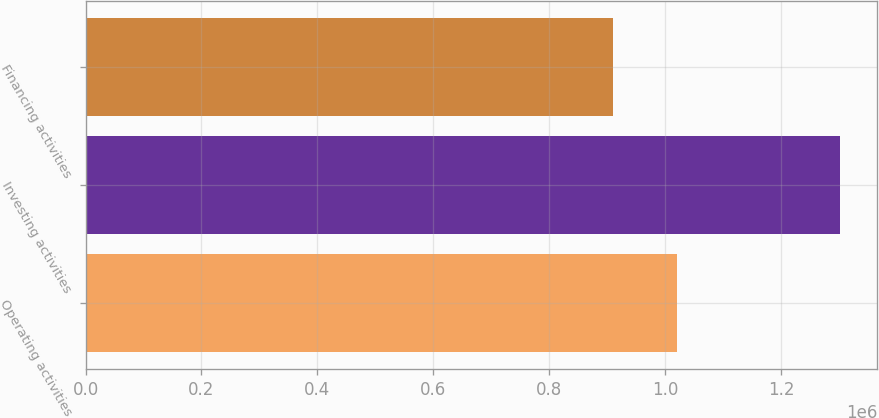<chart> <loc_0><loc_0><loc_500><loc_500><bar_chart><fcel>Operating activities<fcel>Investing activities<fcel>Financing activities<nl><fcel>1.02098e+06<fcel>1.3009e+06<fcel>910330<nl></chart> 